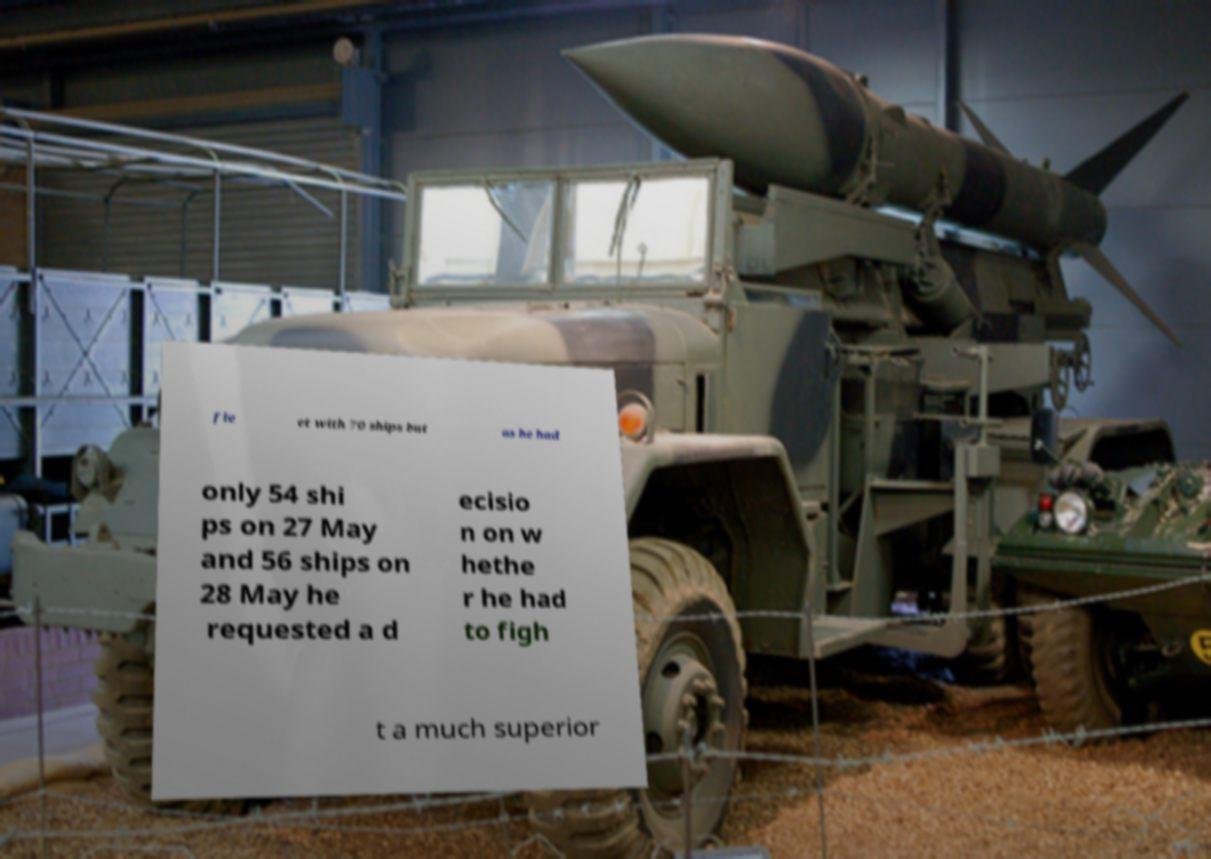There's text embedded in this image that I need extracted. Can you transcribe it verbatim? fle et with 70 ships but as he had only 54 shi ps on 27 May and 56 ships on 28 May he requested a d ecisio n on w hethe r he had to figh t a much superior 